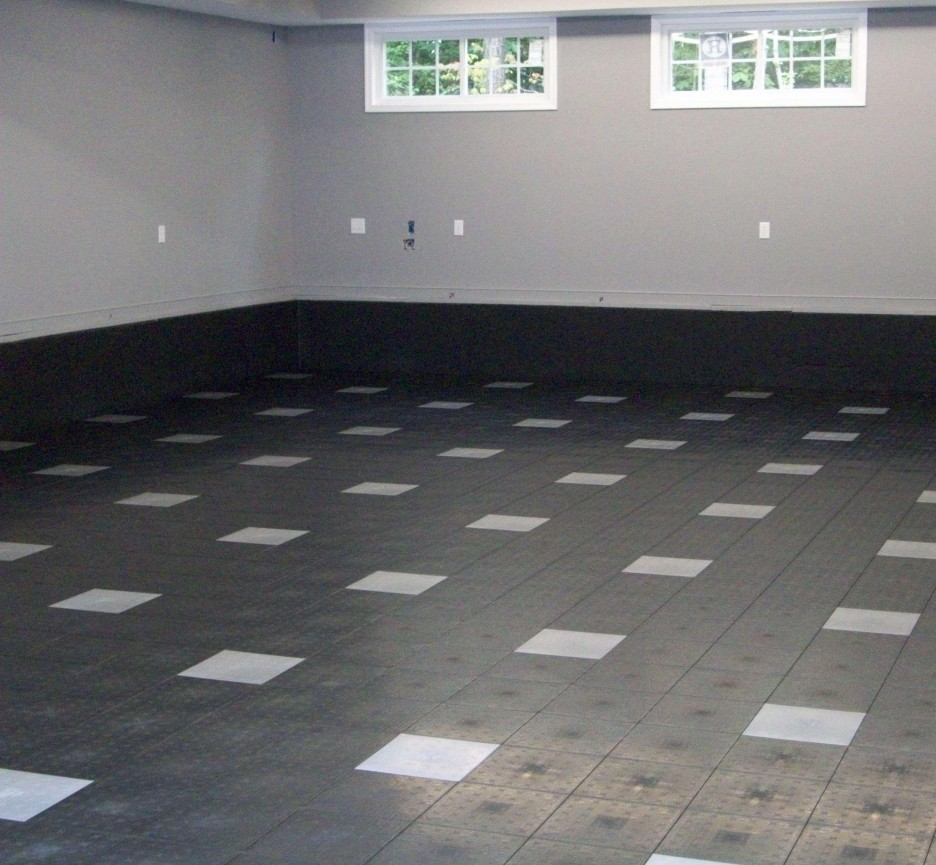What could be the purpose of this room based on the design and features observed? The room in the image, with its checkerboard pattern floor and minimalistic walls, suggests a utilitarian yet playful design, likely intended for varied use. This could be a multipurpose room, ideal as a game room, a workshop for crafts or DIY projects, or even a dance studio. The durable flooring indicates suitability for activities that require easy maintenance and cleaning, while the sparse wall fixtures hint at the potential for installing custom shelves or equipment. Furthermore, the presence of large windows provides adequate natural light, making it an inviting space for activities that benefit from such ambience. 